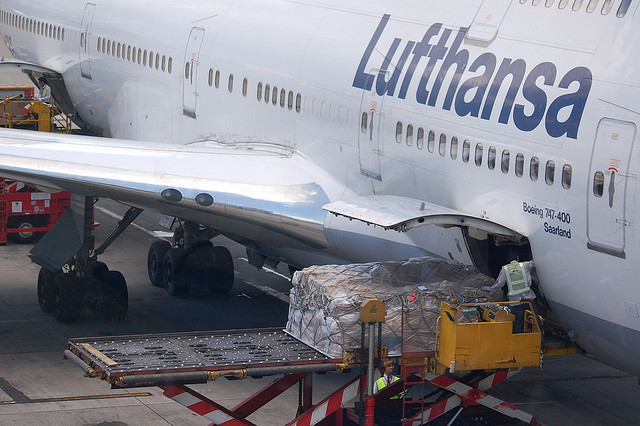Please transcribe the text in this image. Lufthansa 747-400 